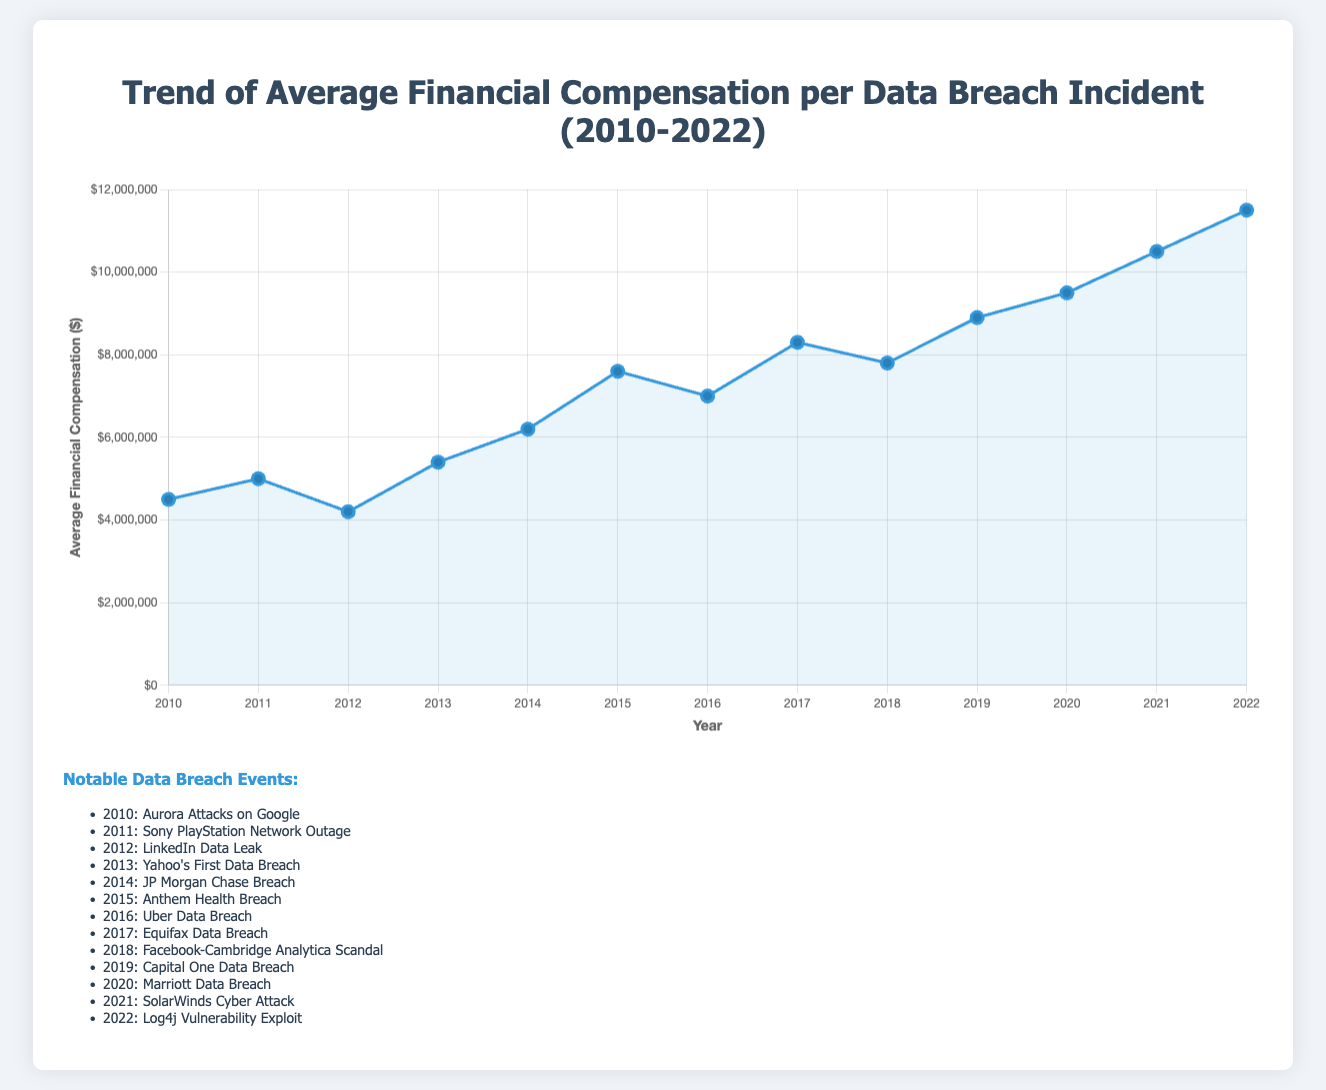What is the trend observed in the average financial compensation from 2010 to 2022? The trend shows a general increase in average financial compensation over time, starting from $4.5 million in 2010 to $11.5 million in 2022.
Answer: General increase Which year had the highest average financial compensation, and what was the amount? By observing the highest point on the line chart, it is clear that 2022 had the highest average financial compensation at $11.5 million.
Answer: 2022, $11.5 million How does the average financial compensation in 2017 compare to that in 2018? In 2017, the average financial compensation was $8.3 million, and in 2018, it was $7.8 million. Therefore, the compensation in 2017 was higher.
Answer: 2017 is higher What notable event occurred in the year with the second-highest average financial compensation, and what was the amount? Observing the chart, 2021 had the second-highest compensation of $10.5 million, and the notable event was the SolarWinds Cyber Attack.
Answer: SolarWinds Cyber Attack, $10.5 million Calculate the total increase in average financial compensation from 2010 to 2022. The compensation in 2010 was $4.5 million, and in 2022 it was $11.5 million. The total increase is $11.5 million - $4.5 million = $7 million.
Answer: $7 million What was the approximate average financial compensation over the period from 2010 to 2012? The average over the three years is calculated as: (4.5 million + 5 million + 4.2 million) / 3 = 13.7 million / 3 ≈ 4.57 million.
Answer: $4.57 million Which two consecutive years showed the sharpest increase in financial compensation? The sharpest increase can be seen between 2020 ($9.5 million) and 2021 ($10.5 million), which is an increase of $1 million.
Answer: 2020 to 2021 Identify the years where the average financial compensation decreased compared to the previous year. By reviewing the chart, compensation decreased from 2011 to 2012, and from 2018 to 2019.
Answer: 2011 to 2012 and 2018 to 2019 What is the notable event associated with the year 2019, and what was the compensation amount? The notable event for 2019 was the Capital One Data Breach, with a compensation of $8.9 million.
Answer: Capital One Data Breach, $8.9 million 